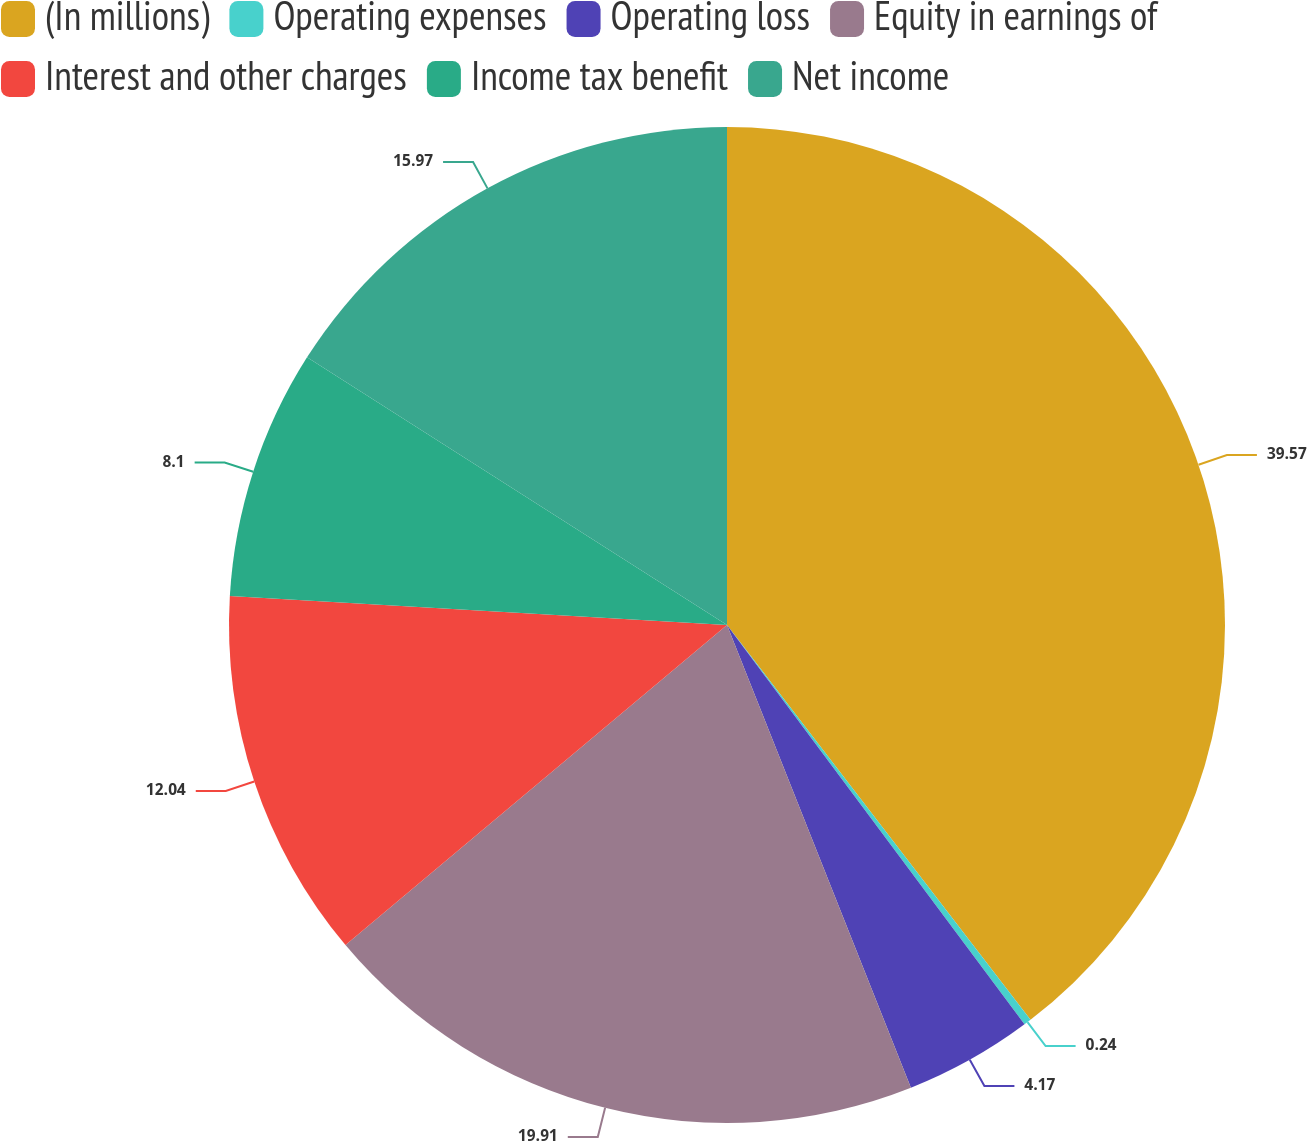<chart> <loc_0><loc_0><loc_500><loc_500><pie_chart><fcel>(In millions)<fcel>Operating expenses<fcel>Operating loss<fcel>Equity in earnings of<fcel>Interest and other charges<fcel>Income tax benefit<fcel>Net income<nl><fcel>39.57%<fcel>0.24%<fcel>4.17%<fcel>19.91%<fcel>12.04%<fcel>8.1%<fcel>15.97%<nl></chart> 